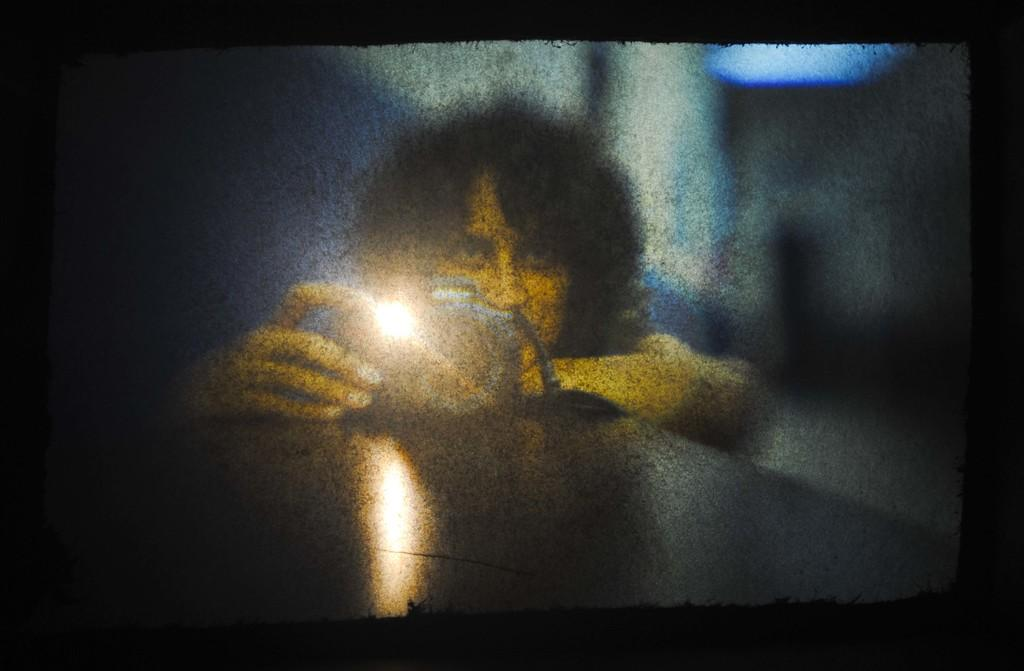What is the main subject of the image? There is a person in the image. What can be seen on the screen in the image? There are lights visible in a screen in the image. What type of blood is visible on the person's hands in the image? There is no blood visible on the person's hands in the image. How much salt is present on the person's face in the image? There is no salt present on the person's face in the image. 